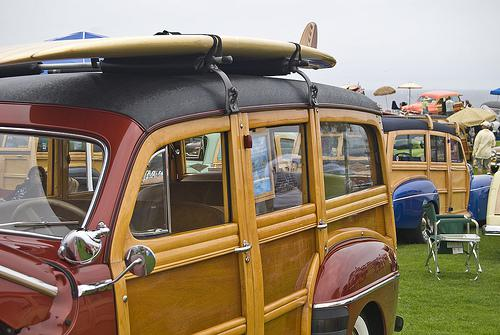Question: what is on the car?
Choices:
A. Luggage.
B. A chair.
C. Surfboard.
D. Mattress.
Answer with the letter. Answer: C Question: what is on the ground?
Choices:
A. Gravel.
B. Cars.
C. Sand.
D. Dirt.
Answer with the letter. Answer: B Question: where is the chair?
Choices:
A. Behind the car.
B. In front of the house.
C. Next to the people.
D. Under the deck.
Answer with the letter. Answer: A 